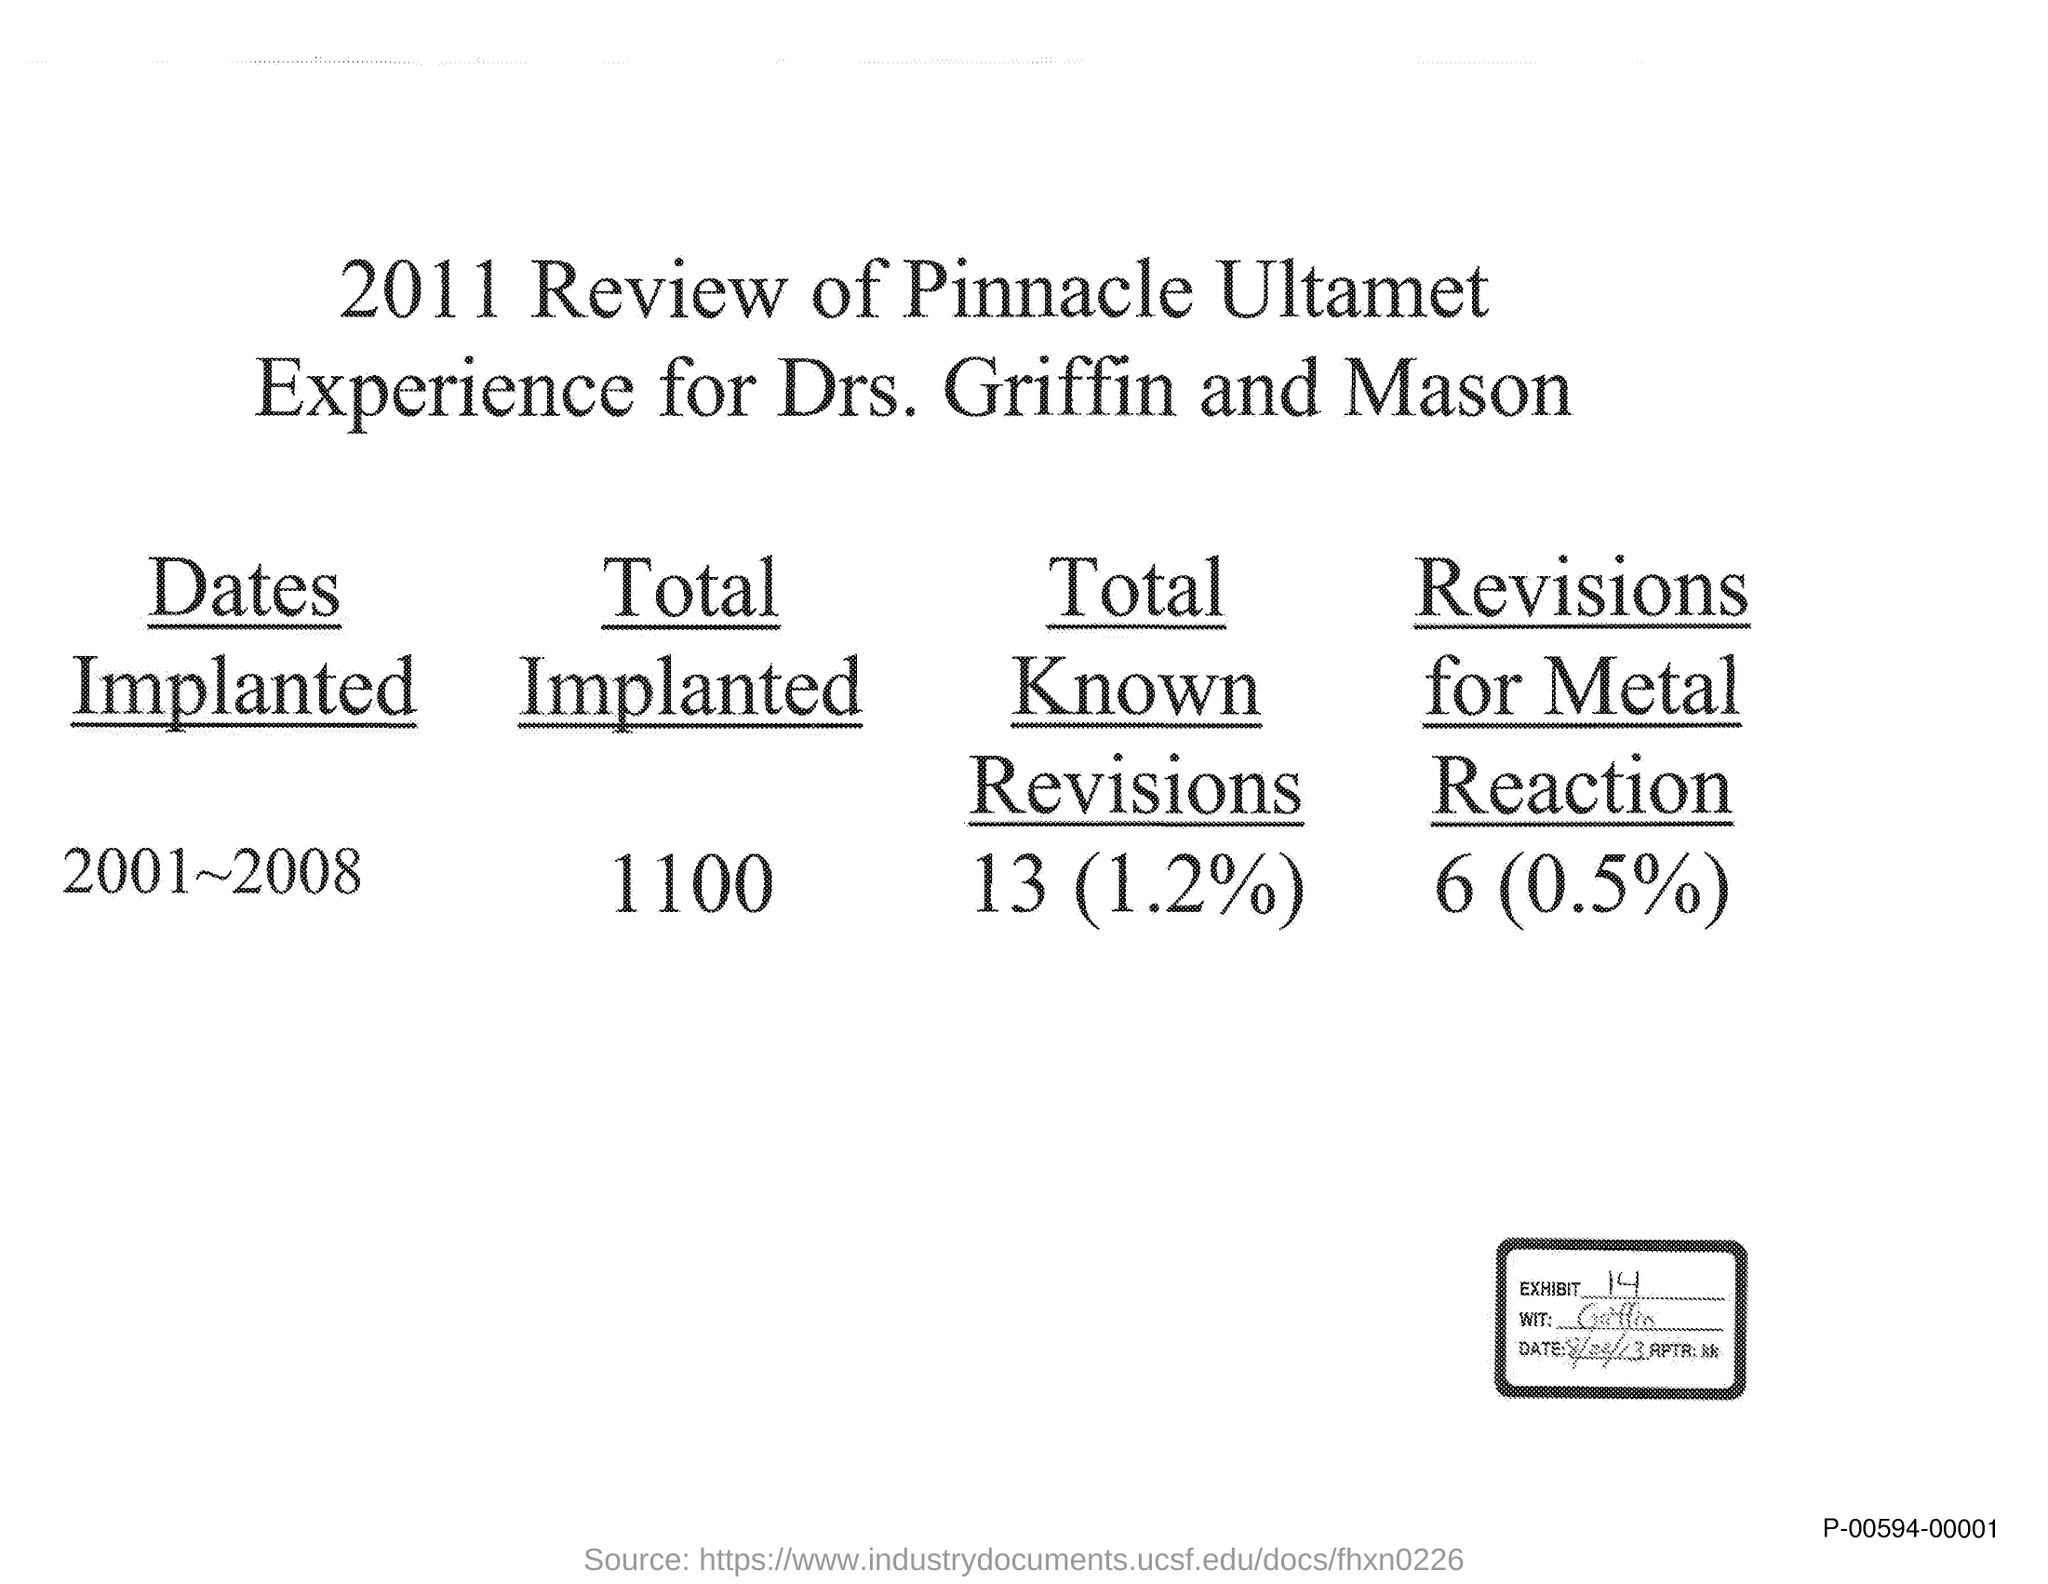What is the Exhibit number?
Keep it short and to the point. 14. What is the total number of implanted?
Provide a short and direct response. 1100. 